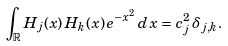Convert formula to latex. <formula><loc_0><loc_0><loc_500><loc_500>\int _ { \mathbb { R } } H _ { j } ( x ) \, H _ { k } ( x ) \, e ^ { - x ^ { 2 } } \, d \, x = c _ { j } ^ { 2 } \, \delta _ { j , k } .</formula> 